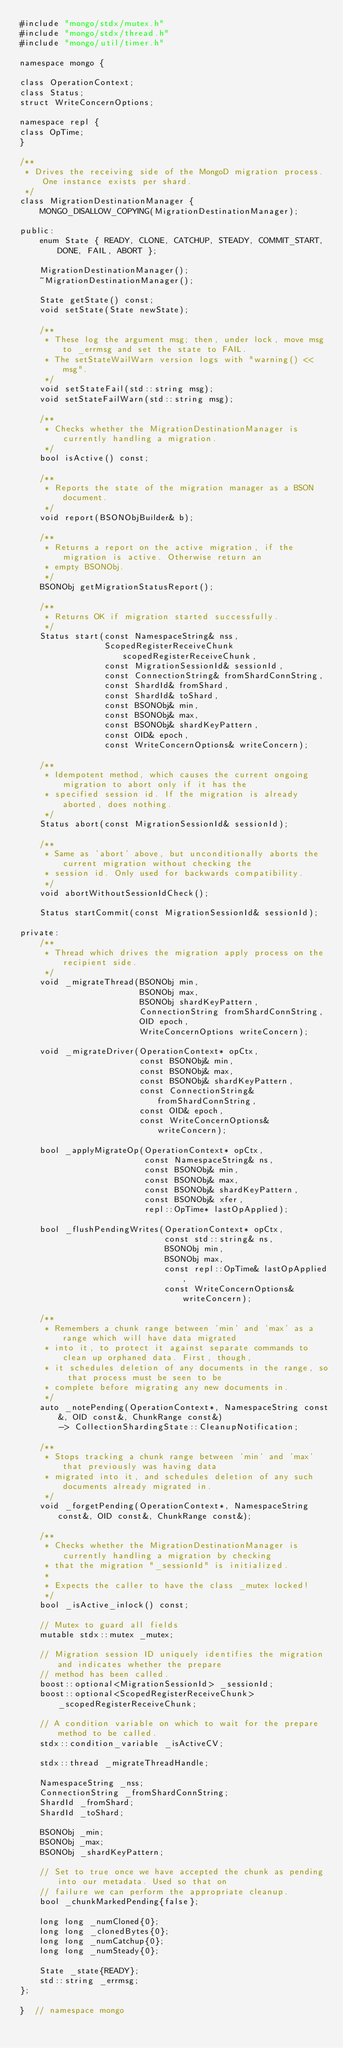<code> <loc_0><loc_0><loc_500><loc_500><_C_>#include "mongo/stdx/mutex.h"
#include "mongo/stdx/thread.h"
#include "mongo/util/timer.h"

namespace mongo {

class OperationContext;
class Status;
struct WriteConcernOptions;

namespace repl {
class OpTime;
}

/**
 * Drives the receiving side of the MongoD migration process. One instance exists per shard.
 */
class MigrationDestinationManager {
    MONGO_DISALLOW_COPYING(MigrationDestinationManager);

public:
    enum State { READY, CLONE, CATCHUP, STEADY, COMMIT_START, DONE, FAIL, ABORT };

    MigrationDestinationManager();
    ~MigrationDestinationManager();

    State getState() const;
    void setState(State newState);

    /**
     * These log the argument msg; then, under lock, move msg to _errmsg and set the state to FAIL.
     * The setStateWailWarn version logs with "warning() << msg".
     */
    void setStateFail(std::string msg);
    void setStateFailWarn(std::string msg);

    /**
     * Checks whether the MigrationDestinationManager is currently handling a migration.
     */
    bool isActive() const;

    /**
     * Reports the state of the migration manager as a BSON document.
     */
    void report(BSONObjBuilder& b);

    /**
     * Returns a report on the active migration, if the migration is active. Otherwise return an
     * empty BSONObj.
     */
    BSONObj getMigrationStatusReport();

    /**
     * Returns OK if migration started successfully.
     */
    Status start(const NamespaceString& nss,
                 ScopedRegisterReceiveChunk scopedRegisterReceiveChunk,
                 const MigrationSessionId& sessionId,
                 const ConnectionString& fromShardConnString,
                 const ShardId& fromShard,
                 const ShardId& toShard,
                 const BSONObj& min,
                 const BSONObj& max,
                 const BSONObj& shardKeyPattern,
                 const OID& epoch,
                 const WriteConcernOptions& writeConcern);

    /**
     * Idempotent method, which causes the current ongoing migration to abort only if it has the
     * specified session id. If the migration is already aborted, does nothing.
     */
    Status abort(const MigrationSessionId& sessionId);

    /**
     * Same as 'abort' above, but unconditionally aborts the current migration without checking the
     * session id. Only used for backwards compatibility.
     */
    void abortWithoutSessionIdCheck();

    Status startCommit(const MigrationSessionId& sessionId);

private:
    /**
     * Thread which drives the migration apply process on the recipient side.
     */
    void _migrateThread(BSONObj min,
                        BSONObj max,
                        BSONObj shardKeyPattern,
                        ConnectionString fromShardConnString,
                        OID epoch,
                        WriteConcernOptions writeConcern);

    void _migrateDriver(OperationContext* opCtx,
                        const BSONObj& min,
                        const BSONObj& max,
                        const BSONObj& shardKeyPattern,
                        const ConnectionString& fromShardConnString,
                        const OID& epoch,
                        const WriteConcernOptions& writeConcern);

    bool _applyMigrateOp(OperationContext* opCtx,
                         const NamespaceString& ns,
                         const BSONObj& min,
                         const BSONObj& max,
                         const BSONObj& shardKeyPattern,
                         const BSONObj& xfer,
                         repl::OpTime* lastOpApplied);

    bool _flushPendingWrites(OperationContext* opCtx,
                             const std::string& ns,
                             BSONObj min,
                             BSONObj max,
                             const repl::OpTime& lastOpApplied,
                             const WriteConcernOptions& writeConcern);

    /**
     * Remembers a chunk range between 'min' and 'max' as a range which will have data migrated
     * into it, to protect it against separate commands to clean up orphaned data. First, though,
     * it schedules deletion of any documents in the range, so that process must be seen to be
     * complete before migrating any new documents in.
     */
    auto _notePending(OperationContext*, NamespaceString const&, OID const&, ChunkRange const&)
        -> CollectionShardingState::CleanupNotification;

    /**
     * Stops tracking a chunk range between 'min' and 'max' that previously was having data
     * migrated into it, and schedules deletion of any such documents already migrated in.
     */
    void _forgetPending(OperationContext*, NamespaceString const&, OID const&, ChunkRange const&);

    /**
     * Checks whether the MigrationDestinationManager is currently handling a migration by checking
     * that the migration "_sessionId" is initialized.
     *
     * Expects the caller to have the class _mutex locked!
     */
    bool _isActive_inlock() const;

    // Mutex to guard all fields
    mutable stdx::mutex _mutex;

    // Migration session ID uniquely identifies the migration and indicates whether the prepare
    // method has been called.
    boost::optional<MigrationSessionId> _sessionId;
    boost::optional<ScopedRegisterReceiveChunk> _scopedRegisterReceiveChunk;

    // A condition variable on which to wait for the prepare method to be called.
    stdx::condition_variable _isActiveCV;

    stdx::thread _migrateThreadHandle;

    NamespaceString _nss;
    ConnectionString _fromShardConnString;
    ShardId _fromShard;
    ShardId _toShard;

    BSONObj _min;
    BSONObj _max;
    BSONObj _shardKeyPattern;

    // Set to true once we have accepted the chunk as pending into our metadata. Used so that on
    // failure we can perform the appropriate cleanup.
    bool _chunkMarkedPending{false};

    long long _numCloned{0};
    long long _clonedBytes{0};
    long long _numCatchup{0};
    long long _numSteady{0};

    State _state{READY};
    std::string _errmsg;
};

}  // namespace mongo
</code> 